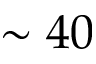Convert formula to latex. <formula><loc_0><loc_0><loc_500><loc_500>\sim 4 0</formula> 